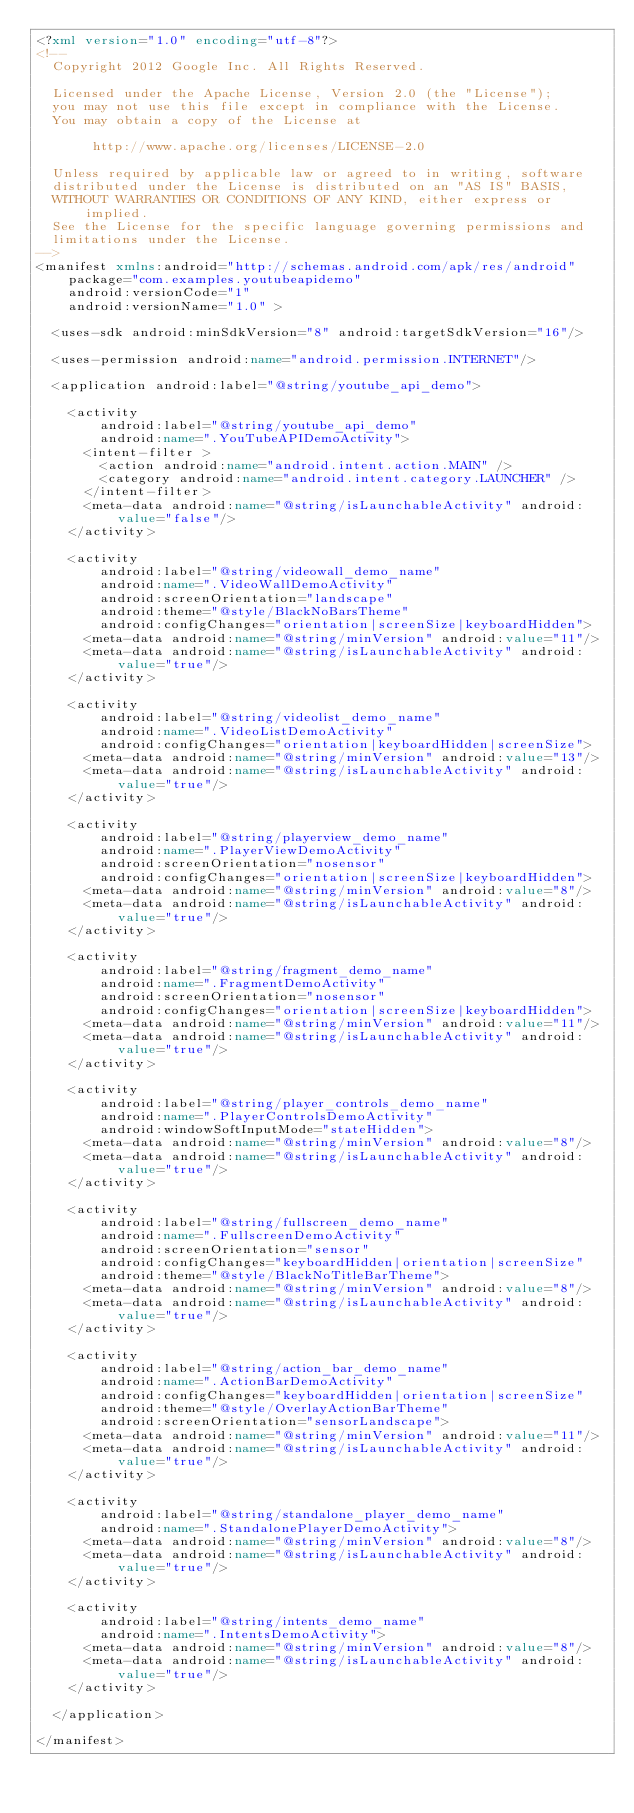Convert code to text. <code><loc_0><loc_0><loc_500><loc_500><_XML_><?xml version="1.0" encoding="utf-8"?>
<!--
  Copyright 2012 Google Inc. All Rights Reserved.

  Licensed under the Apache License, Version 2.0 (the "License");
  you may not use this file except in compliance with the License.
  You may obtain a copy of the License at

       http://www.apache.org/licenses/LICENSE-2.0

  Unless required by applicable law or agreed to in writing, software
  distributed under the License is distributed on an "AS IS" BASIS,
  WITHOUT WARRANTIES OR CONDITIONS OF ANY KIND, either express or implied.
  See the License for the specific language governing permissions and
  limitations under the License.
-->
<manifest xmlns:android="http://schemas.android.com/apk/res/android"
    package="com.examples.youtubeapidemo"
    android:versionCode="1"
    android:versionName="1.0" >

  <uses-sdk android:minSdkVersion="8" android:targetSdkVersion="16"/>

  <uses-permission android:name="android.permission.INTERNET"/>

  <application android:label="@string/youtube_api_demo">

    <activity
        android:label="@string/youtube_api_demo"
        android:name=".YouTubeAPIDemoActivity">
      <intent-filter >
        <action android:name="android.intent.action.MAIN" />
        <category android:name="android.intent.category.LAUNCHER" />
      </intent-filter>
      <meta-data android:name="@string/isLaunchableActivity" android:value="false"/>
    </activity>

    <activity
        android:label="@string/videowall_demo_name"
        android:name=".VideoWallDemoActivity"
        android:screenOrientation="landscape"
        android:theme="@style/BlackNoBarsTheme"
        android:configChanges="orientation|screenSize|keyboardHidden">
      <meta-data android:name="@string/minVersion" android:value="11"/>
      <meta-data android:name="@string/isLaunchableActivity" android:value="true"/>
    </activity>

    <activity
        android:label="@string/videolist_demo_name"
        android:name=".VideoListDemoActivity"
        android:configChanges="orientation|keyboardHidden|screenSize">
      <meta-data android:name="@string/minVersion" android:value="13"/>
      <meta-data android:name="@string/isLaunchableActivity" android:value="true"/>
    </activity>

    <activity
        android:label="@string/playerview_demo_name"
        android:name=".PlayerViewDemoActivity"
        android:screenOrientation="nosensor"
        android:configChanges="orientation|screenSize|keyboardHidden">
      <meta-data android:name="@string/minVersion" android:value="8"/>
      <meta-data android:name="@string/isLaunchableActivity" android:value="true"/>
    </activity>

    <activity
        android:label="@string/fragment_demo_name"
        android:name=".FragmentDemoActivity"
        android:screenOrientation="nosensor"
        android:configChanges="orientation|screenSize|keyboardHidden">
      <meta-data android:name="@string/minVersion" android:value="11"/>
      <meta-data android:name="@string/isLaunchableActivity" android:value="true"/>
    </activity>

    <activity
        android:label="@string/player_controls_demo_name"
        android:name=".PlayerControlsDemoActivity"
        android:windowSoftInputMode="stateHidden">
      <meta-data android:name="@string/minVersion" android:value="8"/>
      <meta-data android:name="@string/isLaunchableActivity" android:value="true"/>
    </activity>

    <activity
        android:label="@string/fullscreen_demo_name"
        android:name=".FullscreenDemoActivity"
        android:screenOrientation="sensor"
        android:configChanges="keyboardHidden|orientation|screenSize"
        android:theme="@style/BlackNoTitleBarTheme">
      <meta-data android:name="@string/minVersion" android:value="8"/>
      <meta-data android:name="@string/isLaunchableActivity" android:value="true"/>
    </activity>

    <activity
        android:label="@string/action_bar_demo_name"
        android:name=".ActionBarDemoActivity"
        android:configChanges="keyboardHidden|orientation|screenSize"
        android:theme="@style/OverlayActionBarTheme"
        android:screenOrientation="sensorLandscape">
      <meta-data android:name="@string/minVersion" android:value="11"/>
      <meta-data android:name="@string/isLaunchableActivity" android:value="true"/>
    </activity>

    <activity
        android:label="@string/standalone_player_demo_name"
        android:name=".StandalonePlayerDemoActivity">
      <meta-data android:name="@string/minVersion" android:value="8"/>
      <meta-data android:name="@string/isLaunchableActivity" android:value="true"/>
    </activity>

    <activity
        android:label="@string/intents_demo_name"
        android:name=".IntentsDemoActivity">
      <meta-data android:name="@string/minVersion" android:value="8"/>
      <meta-data android:name="@string/isLaunchableActivity" android:value="true"/>
    </activity>

  </application>

</manifest>
</code> 